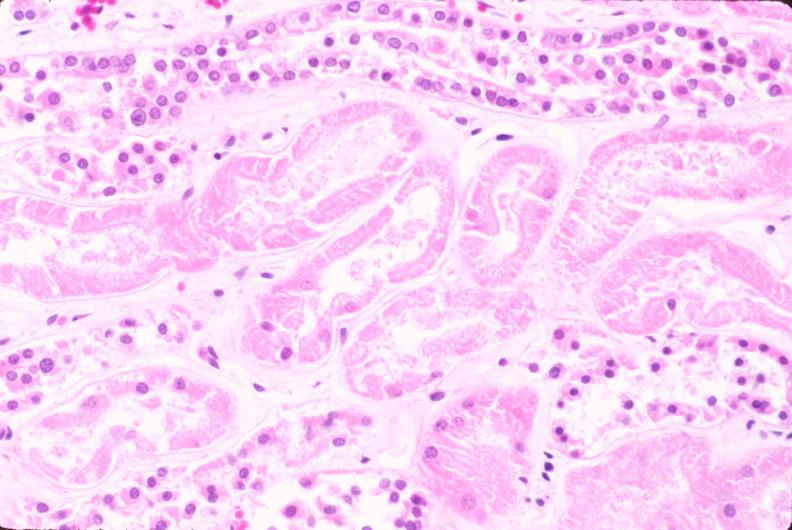does this image show kidney, acute tubular necrosis?
Answer the question using a single word or phrase. Yes 